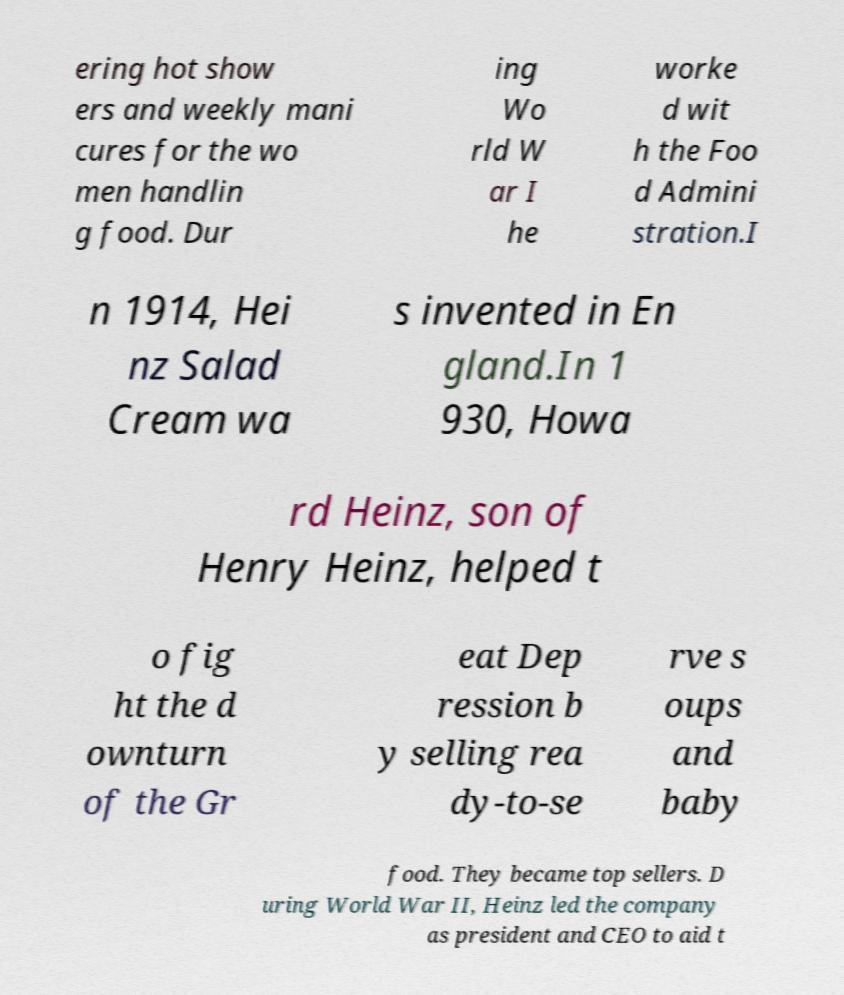Could you extract and type out the text from this image? ering hot show ers and weekly mani cures for the wo men handlin g food. Dur ing Wo rld W ar I he worke d wit h the Foo d Admini stration.I n 1914, Hei nz Salad Cream wa s invented in En gland.In 1 930, Howa rd Heinz, son of Henry Heinz, helped t o fig ht the d ownturn of the Gr eat Dep ression b y selling rea dy-to-se rve s oups and baby food. They became top sellers. D uring World War II, Heinz led the company as president and CEO to aid t 